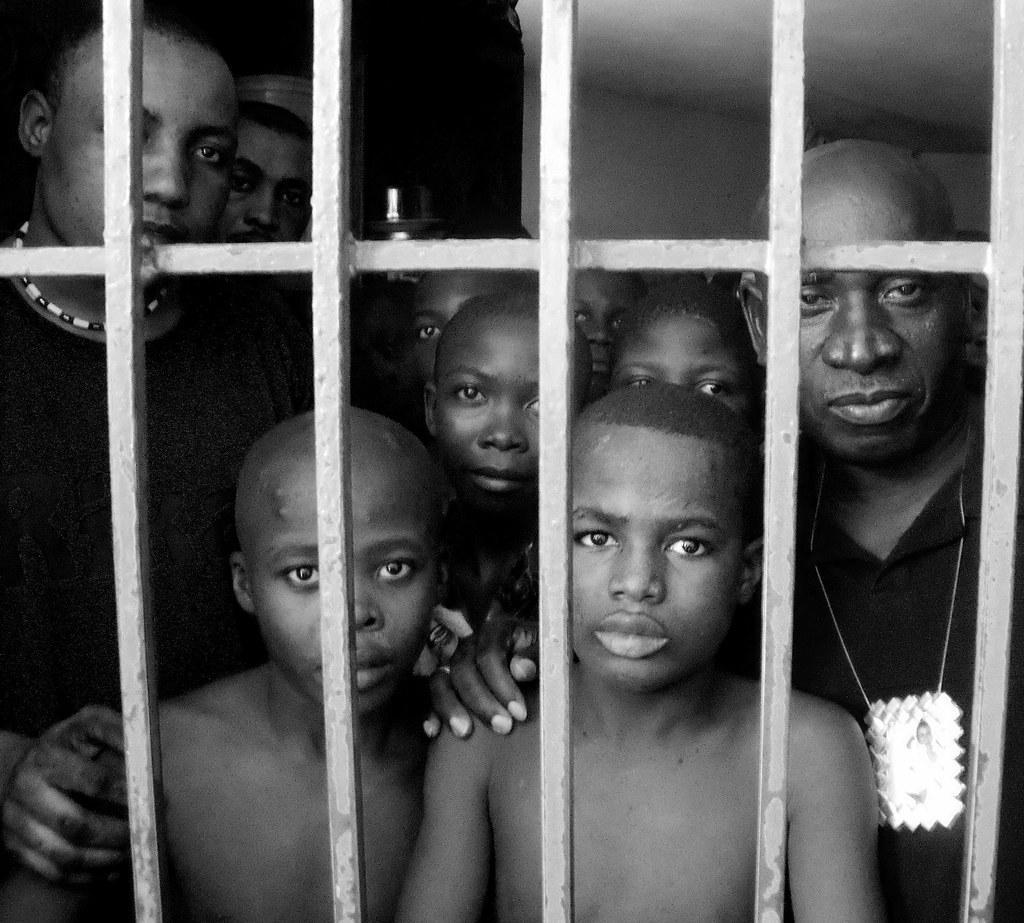Please provide a concise description of this image. This is a black and white picture, in this image we can see a few people and the grille, also we can see the background is dark. 